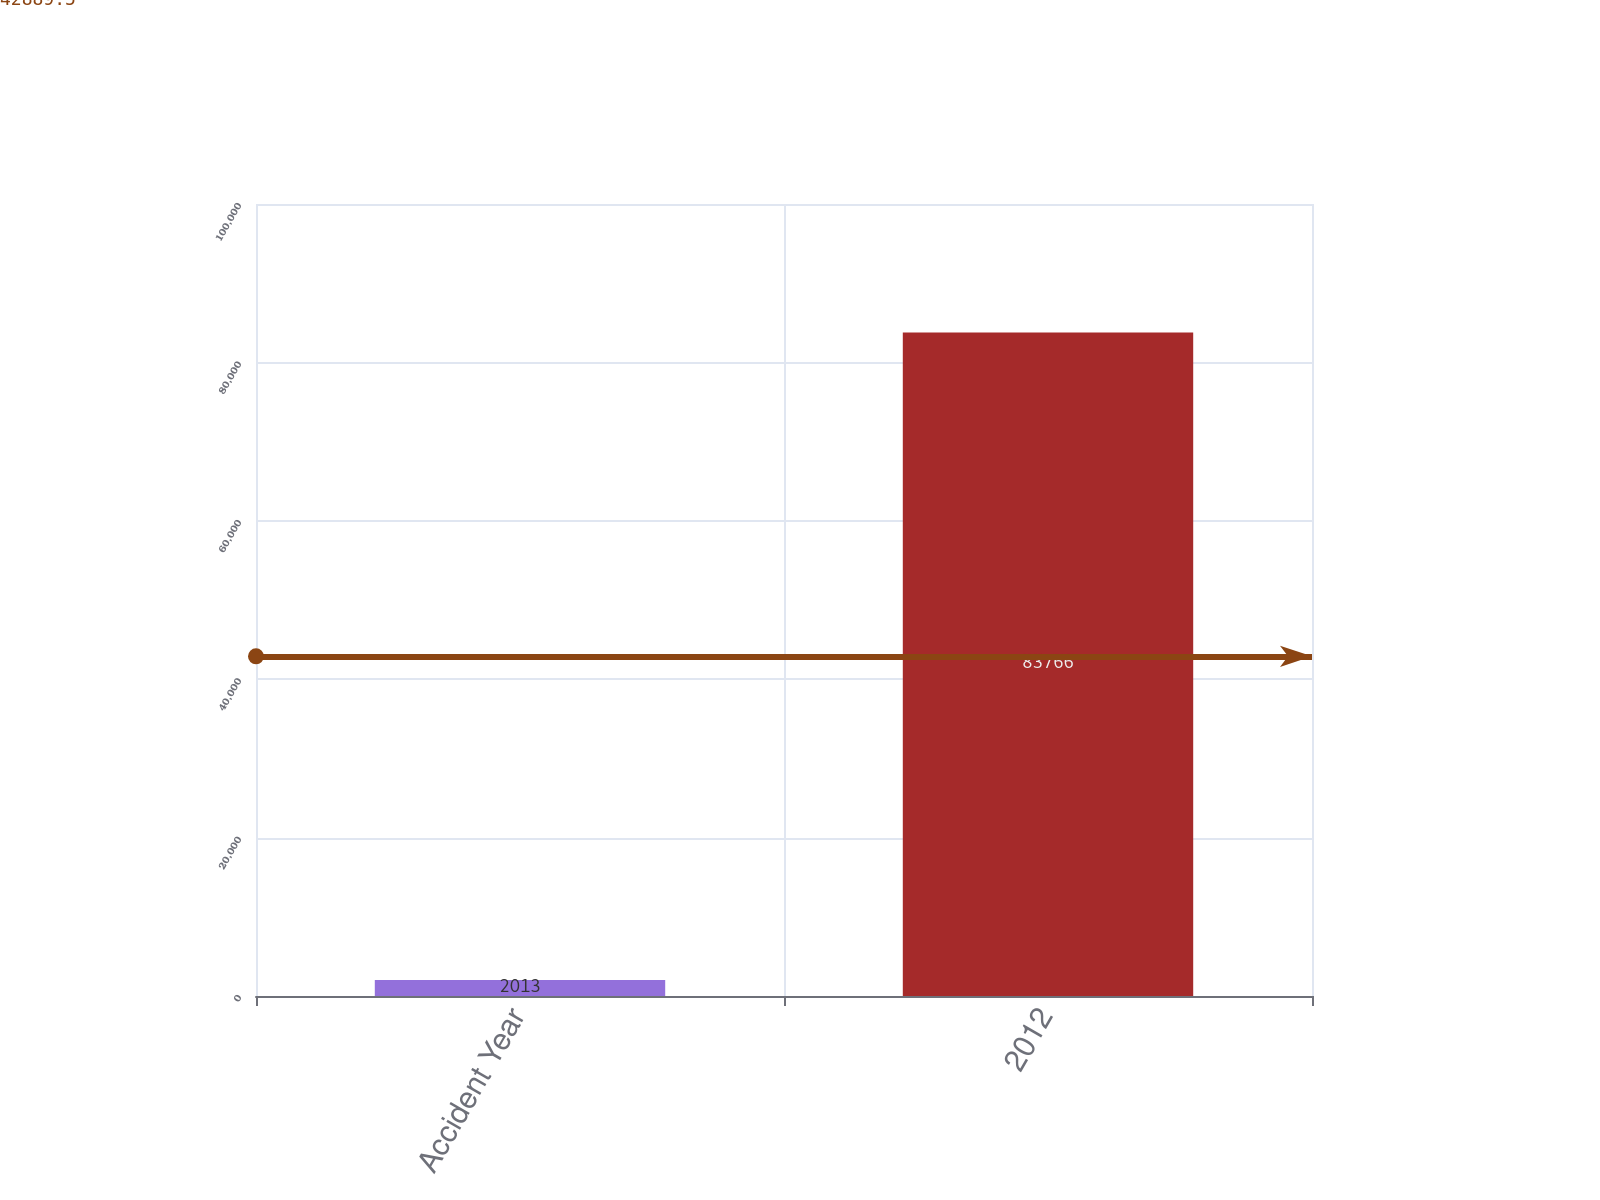Convert chart to OTSL. <chart><loc_0><loc_0><loc_500><loc_500><bar_chart><fcel>Accident Year<fcel>2012<nl><fcel>2013<fcel>83766<nl></chart> 